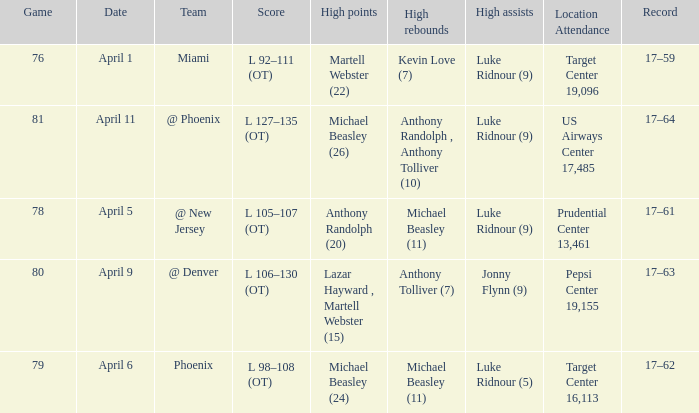What was the score in the game in which Michael Beasley (26) did the high points? L 127–135 (OT). 